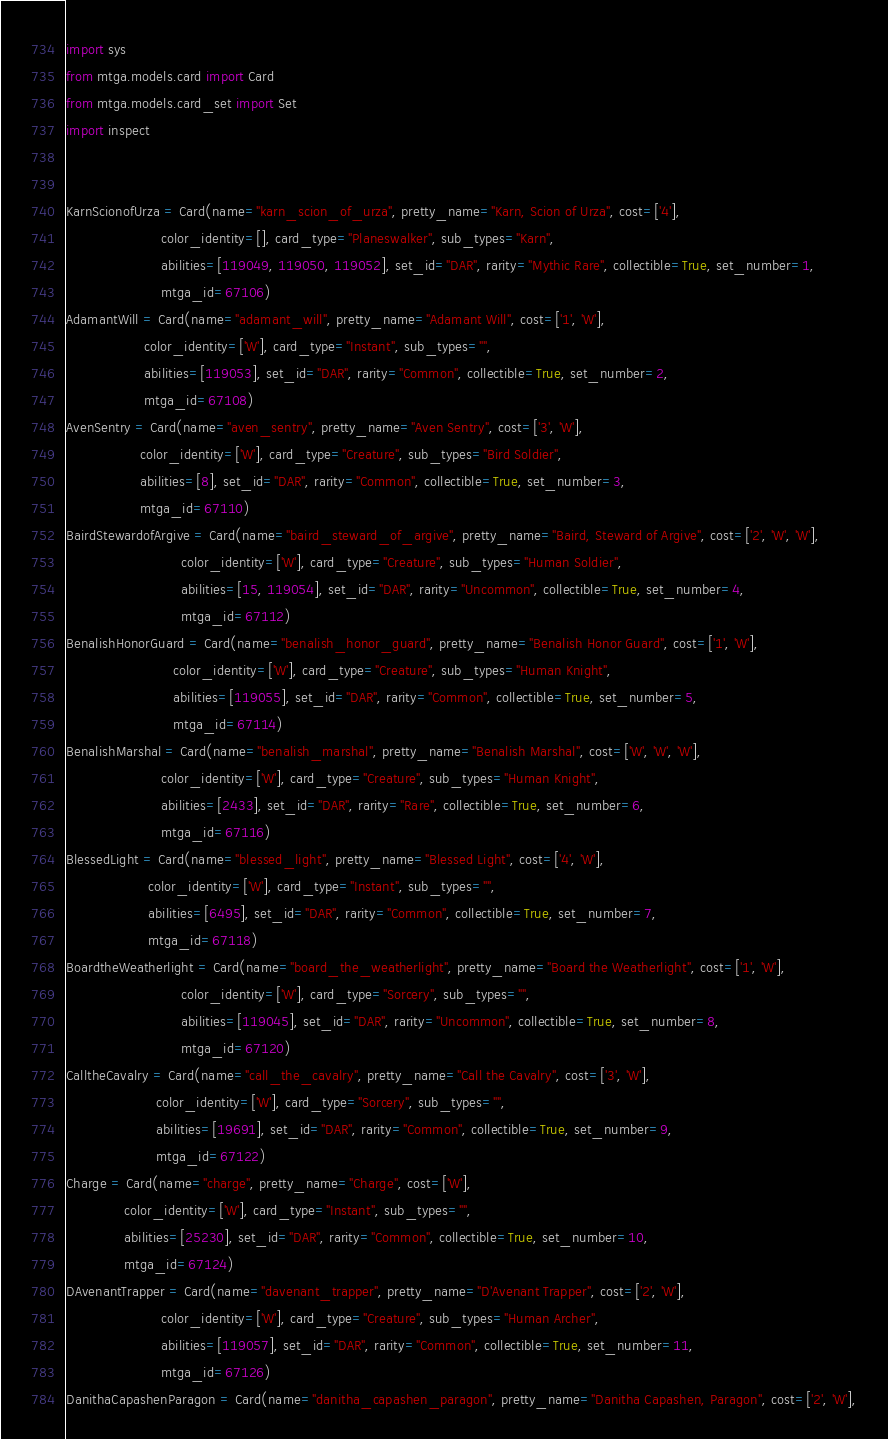<code> <loc_0><loc_0><loc_500><loc_500><_Python_>
import sys
from mtga.models.card import Card
from mtga.models.card_set import Set
import inspect


KarnScionofUrza = Card(name="karn_scion_of_urza", pretty_name="Karn, Scion of Urza", cost=['4'],
                       color_identity=[], card_type="Planeswalker", sub_types="Karn",
                       abilities=[119049, 119050, 119052], set_id="DAR", rarity="Mythic Rare", collectible=True, set_number=1,
                       mtga_id=67106)
AdamantWill = Card(name="adamant_will", pretty_name="Adamant Will", cost=['1', 'W'],
                   color_identity=['W'], card_type="Instant", sub_types="",
                   abilities=[119053], set_id="DAR", rarity="Common", collectible=True, set_number=2,
                   mtga_id=67108)
AvenSentry = Card(name="aven_sentry", pretty_name="Aven Sentry", cost=['3', 'W'],
                  color_identity=['W'], card_type="Creature", sub_types="Bird Soldier",
                  abilities=[8], set_id="DAR", rarity="Common", collectible=True, set_number=3,
                  mtga_id=67110)
BairdStewardofArgive = Card(name="baird_steward_of_argive", pretty_name="Baird, Steward of Argive", cost=['2', 'W', 'W'],
                            color_identity=['W'], card_type="Creature", sub_types="Human Soldier",
                            abilities=[15, 119054], set_id="DAR", rarity="Uncommon", collectible=True, set_number=4,
                            mtga_id=67112)
BenalishHonorGuard = Card(name="benalish_honor_guard", pretty_name="Benalish Honor Guard", cost=['1', 'W'],
                          color_identity=['W'], card_type="Creature", sub_types="Human Knight",
                          abilities=[119055], set_id="DAR", rarity="Common", collectible=True, set_number=5,
                          mtga_id=67114)
BenalishMarshal = Card(name="benalish_marshal", pretty_name="Benalish Marshal", cost=['W', 'W', 'W'],
                       color_identity=['W'], card_type="Creature", sub_types="Human Knight",
                       abilities=[2433], set_id="DAR", rarity="Rare", collectible=True, set_number=6,
                       mtga_id=67116)
BlessedLight = Card(name="blessed_light", pretty_name="Blessed Light", cost=['4', 'W'],
                    color_identity=['W'], card_type="Instant", sub_types="",
                    abilities=[6495], set_id="DAR", rarity="Common", collectible=True, set_number=7,
                    mtga_id=67118)
BoardtheWeatherlight = Card(name="board_the_weatherlight", pretty_name="Board the Weatherlight", cost=['1', 'W'],
                            color_identity=['W'], card_type="Sorcery", sub_types="",
                            abilities=[119045], set_id="DAR", rarity="Uncommon", collectible=True, set_number=8,
                            mtga_id=67120)
CalltheCavalry = Card(name="call_the_cavalry", pretty_name="Call the Cavalry", cost=['3', 'W'],
                      color_identity=['W'], card_type="Sorcery", sub_types="",
                      abilities=[19691], set_id="DAR", rarity="Common", collectible=True, set_number=9,
                      mtga_id=67122)
Charge = Card(name="charge", pretty_name="Charge", cost=['W'],
              color_identity=['W'], card_type="Instant", sub_types="",
              abilities=[25230], set_id="DAR", rarity="Common", collectible=True, set_number=10,
              mtga_id=67124)
DAvenantTrapper = Card(name="davenant_trapper", pretty_name="D'Avenant Trapper", cost=['2', 'W'],
                       color_identity=['W'], card_type="Creature", sub_types="Human Archer",
                       abilities=[119057], set_id="DAR", rarity="Common", collectible=True, set_number=11,
                       mtga_id=67126)
DanithaCapashenParagon = Card(name="danitha_capashen_paragon", pretty_name="Danitha Capashen, Paragon", cost=['2', 'W'],</code> 